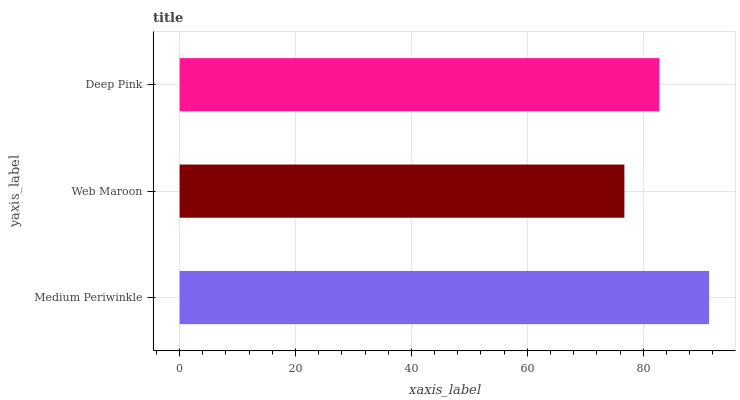Is Web Maroon the minimum?
Answer yes or no. Yes. Is Medium Periwinkle the maximum?
Answer yes or no. Yes. Is Deep Pink the minimum?
Answer yes or no. No. Is Deep Pink the maximum?
Answer yes or no. No. Is Deep Pink greater than Web Maroon?
Answer yes or no. Yes. Is Web Maroon less than Deep Pink?
Answer yes or no. Yes. Is Web Maroon greater than Deep Pink?
Answer yes or no. No. Is Deep Pink less than Web Maroon?
Answer yes or no. No. Is Deep Pink the high median?
Answer yes or no. Yes. Is Deep Pink the low median?
Answer yes or no. Yes. Is Medium Periwinkle the high median?
Answer yes or no. No. Is Web Maroon the low median?
Answer yes or no. No. 